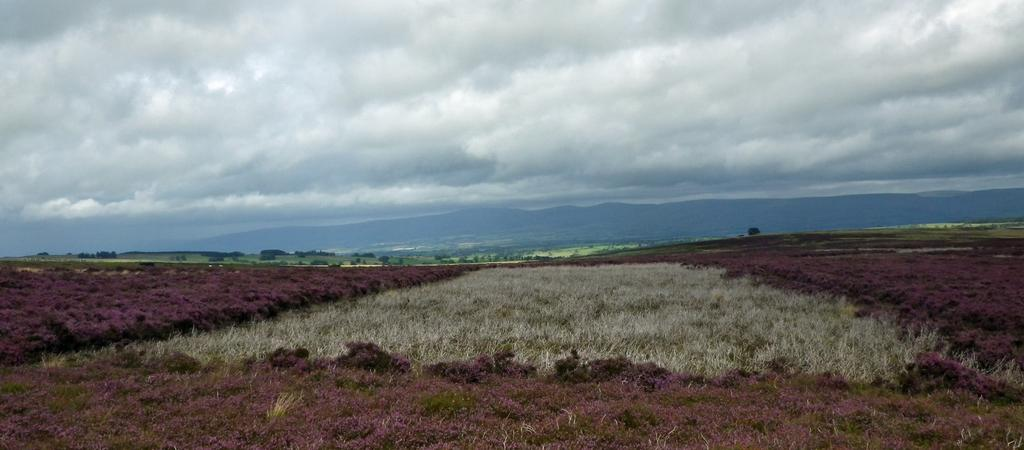What type of vegetation can be seen in the image? There is grass in the image. What other natural elements are present in the image? There are trees and hills in the image. What is visible at the top of the image? The sky is visible at the top of the image. What can be seen in the sky? Clouds are present in the sky. Where is the dad standing in the image? There is no dad present in the image. What type of line can be seen on the stage in the image? There is no stage or line present in the image. 